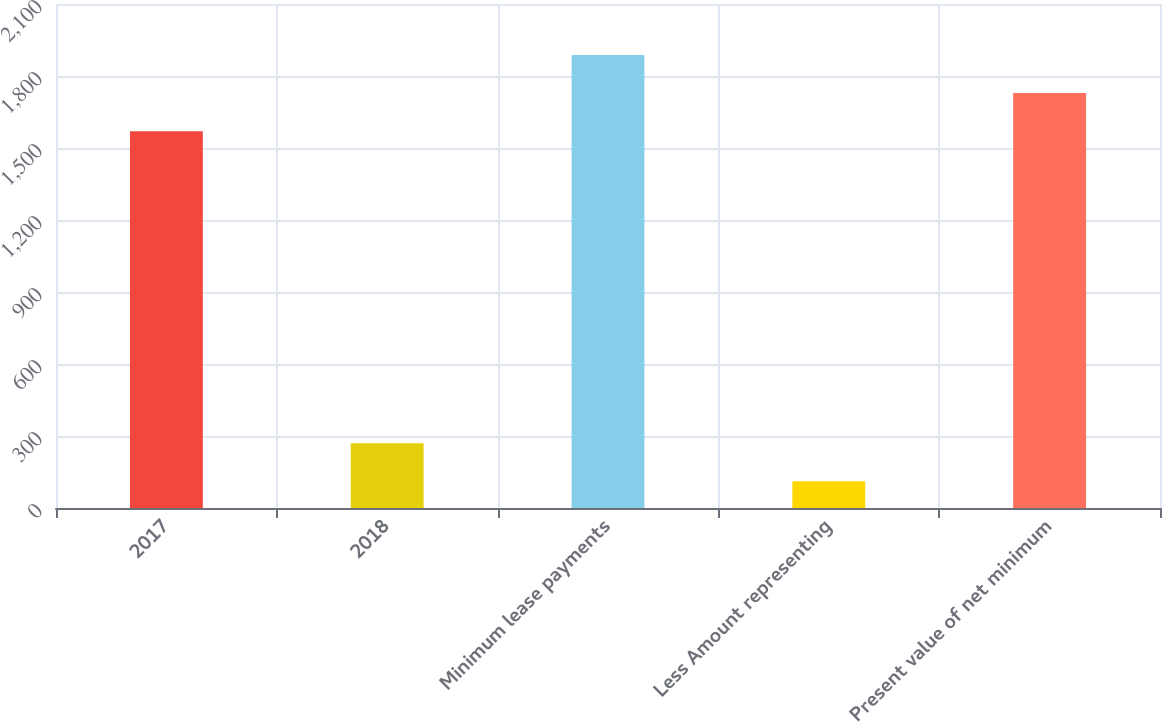<chart> <loc_0><loc_0><loc_500><loc_500><bar_chart><fcel>2017<fcel>2018<fcel>Minimum lease payments<fcel>Less Amount representing<fcel>Present value of net minimum<nl><fcel>1570<fcel>270<fcel>1888<fcel>111<fcel>1729<nl></chart> 